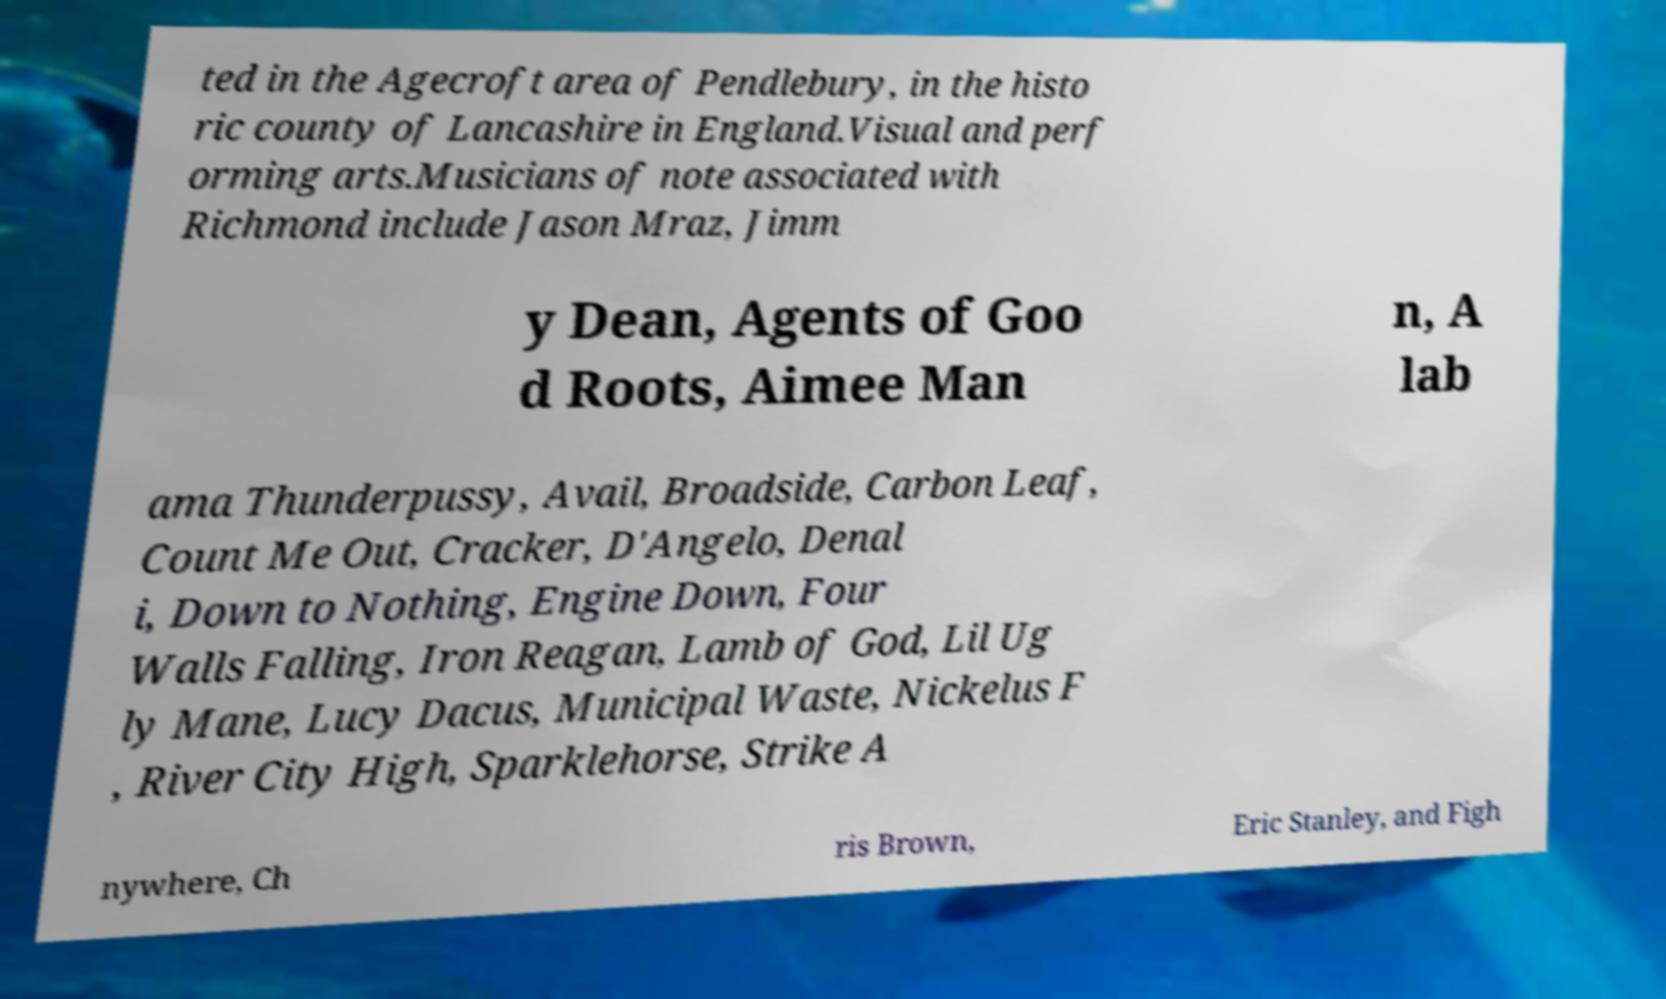Could you assist in decoding the text presented in this image and type it out clearly? ted in the Agecroft area of Pendlebury, in the histo ric county of Lancashire in England.Visual and perf orming arts.Musicians of note associated with Richmond include Jason Mraz, Jimm y Dean, Agents of Goo d Roots, Aimee Man n, A lab ama Thunderpussy, Avail, Broadside, Carbon Leaf, Count Me Out, Cracker, D'Angelo, Denal i, Down to Nothing, Engine Down, Four Walls Falling, Iron Reagan, Lamb of God, Lil Ug ly Mane, Lucy Dacus, Municipal Waste, Nickelus F , River City High, Sparklehorse, Strike A nywhere, Ch ris Brown, Eric Stanley, and Figh 